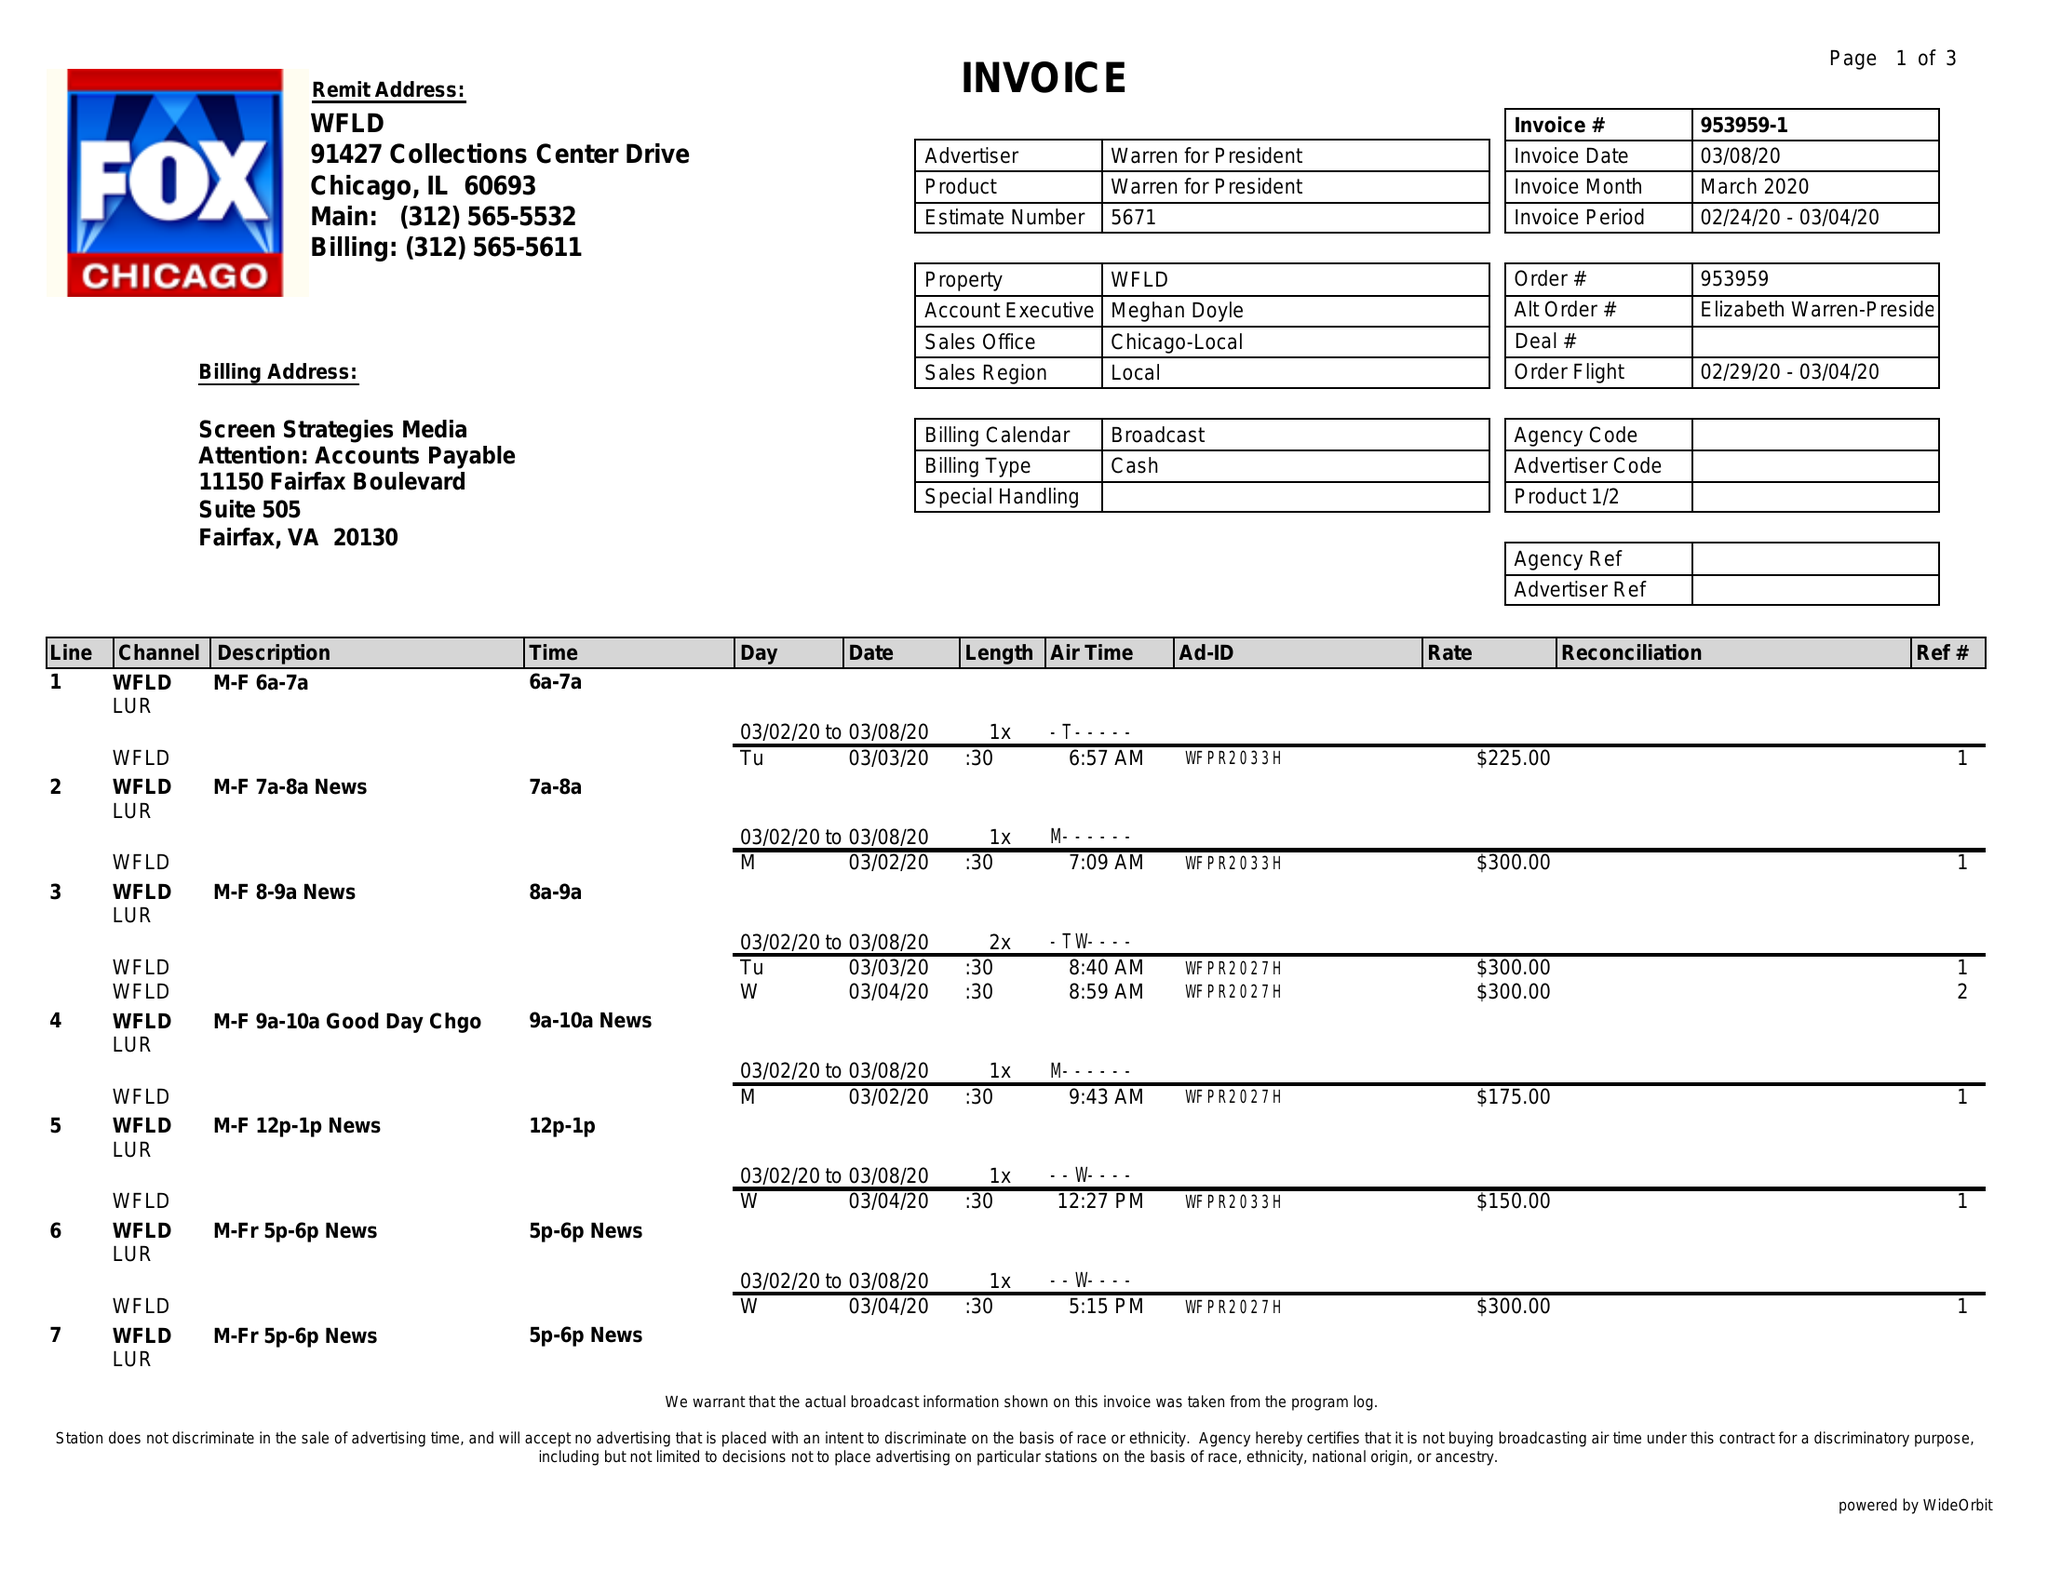What is the value for the flight_from?
Answer the question using a single word or phrase. 02/29/20 